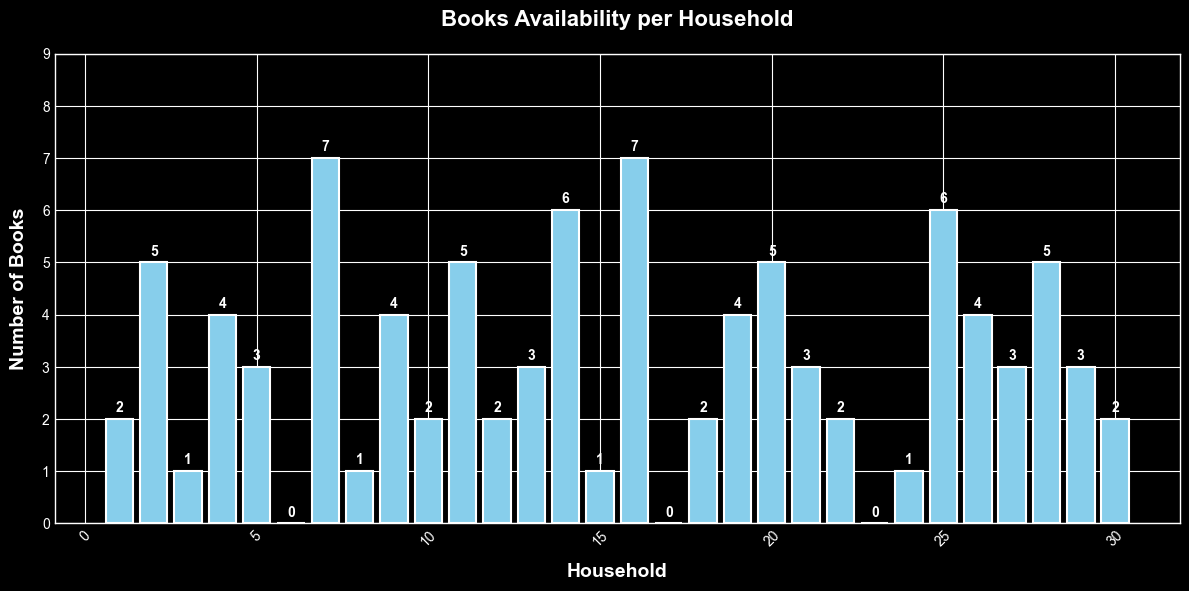Which household has the maximum number of books? The bar with the highest value represents the household with the maximum number of books. In this figure, the highest bar corresponds to households 7 and 16 with 7 books.
Answer: 7 and 16 How many households have zero books? Count the bars that extend up to the zero value on the y-axis. There are three such bars, corresponding to households 6, 17, and 23.
Answer: 3 What is the average number of books per household? To find the average, sum up all the books and divide by the number of households. Total books: 2+5+1+4+3+0+7+1+4+2+5+2+3+6+1+7+0+2+4+5+3+2+0+1+6+4+3+5+3+2 = 89. Number of households: 30. Average = 89 / 30.
Answer: 2.97 Compare the number of books in Household 10 and Household 20. Which household has more books? Household 10 has 2 books and Household 20 has 5 books. Since 5 is greater than 2, Household 20 has more books.
Answer: Household 20 What's the median number of books per household? To find the median, first, sort the number of books in ascending order and find the middle value. Sorted data: 0, 0, 0, 1, 1, 1, 1, 2, 2, 2, 2, 2, 2, 3, 3, 3, 3, 3, 3, 4, 4, 4, 4, 5, 5, 5, 5, 6, 6, 7, 7. The median is the average of the 15th and 16th values (3, 3) in a dataset of 30 values.
Answer: 3 How many households have more than 5 books? Count the number of bars that exceed the value of 5 on the y-axis. Households: 7, 14, 16, and 25 have 7, 6, 7, and 6 books respectively.
Answer: 4 What is the difference between the number of books in Household 25 and Household 13? Household 25 has 6 books, and Household 13 has 3 books. The difference is 6 - 3.
Answer: 3 Which households have exactly 2 books? Identify all the bars that correspond to the value of 2 on the y-axis. Households 1, 10, 12, 18, and 30 have exactly 2 books.
Answer: 1, 10, 12, 18, 30 What is the sum of books available in the first five households? Add the number of books in the first five households: 2 (Household 1) + 5 (Household 2) + 1 (Household 3) + 4 (Household 4) + 3 (Household 5) = 15
Answer: 15 Are there more households with 3 books or with 4 books? Count the bars with the value of 3 and 4. Households with 3 books: 5, 13, 21, 27, 29 (5 households), and households with 4 books: 4, 9, 19, 26 (4 households). Thus, there are more households with 3 books.
Answer: 3 books 